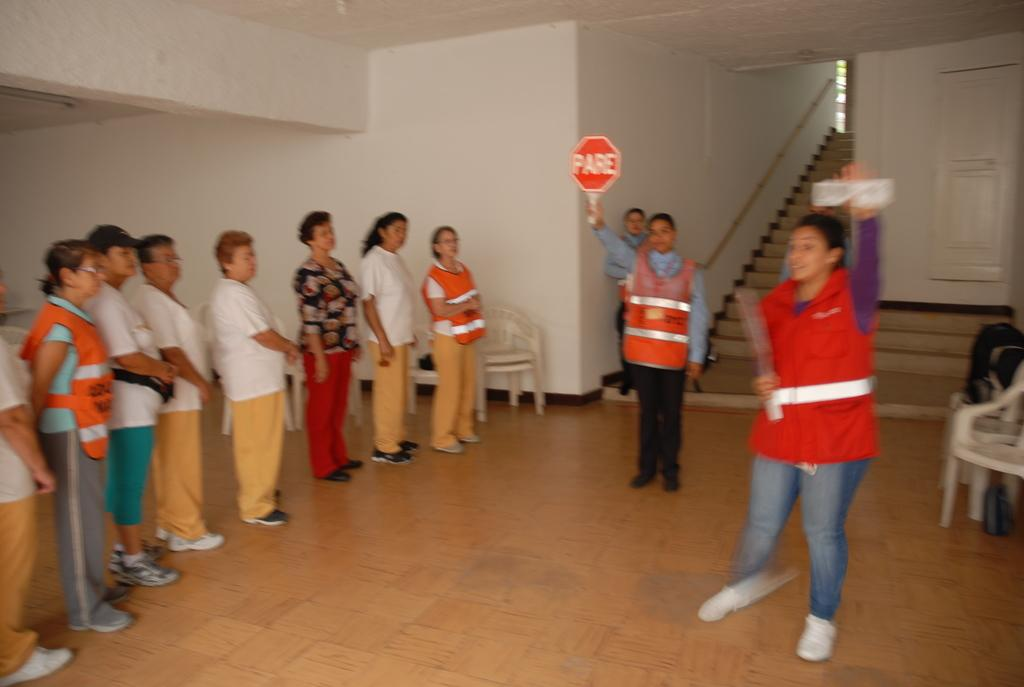<image>
Create a compact narrative representing the image presented. A person holds up a red sign that says PARE. 